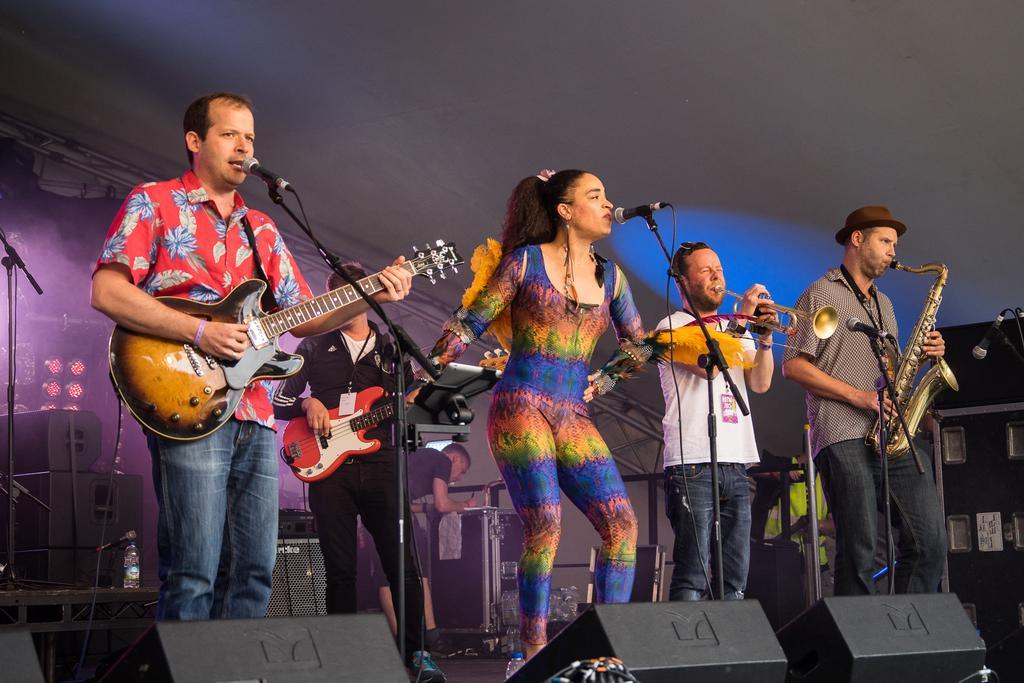Could you give a brief overview of what you see in this image? In this image a man is standing and playing the guitar , another woman singing a song , another man playing trumpet , another man playing saxophone and in the back ground there is another person playing guitar and another person writing in the briefcase , speakers and focus lights. 